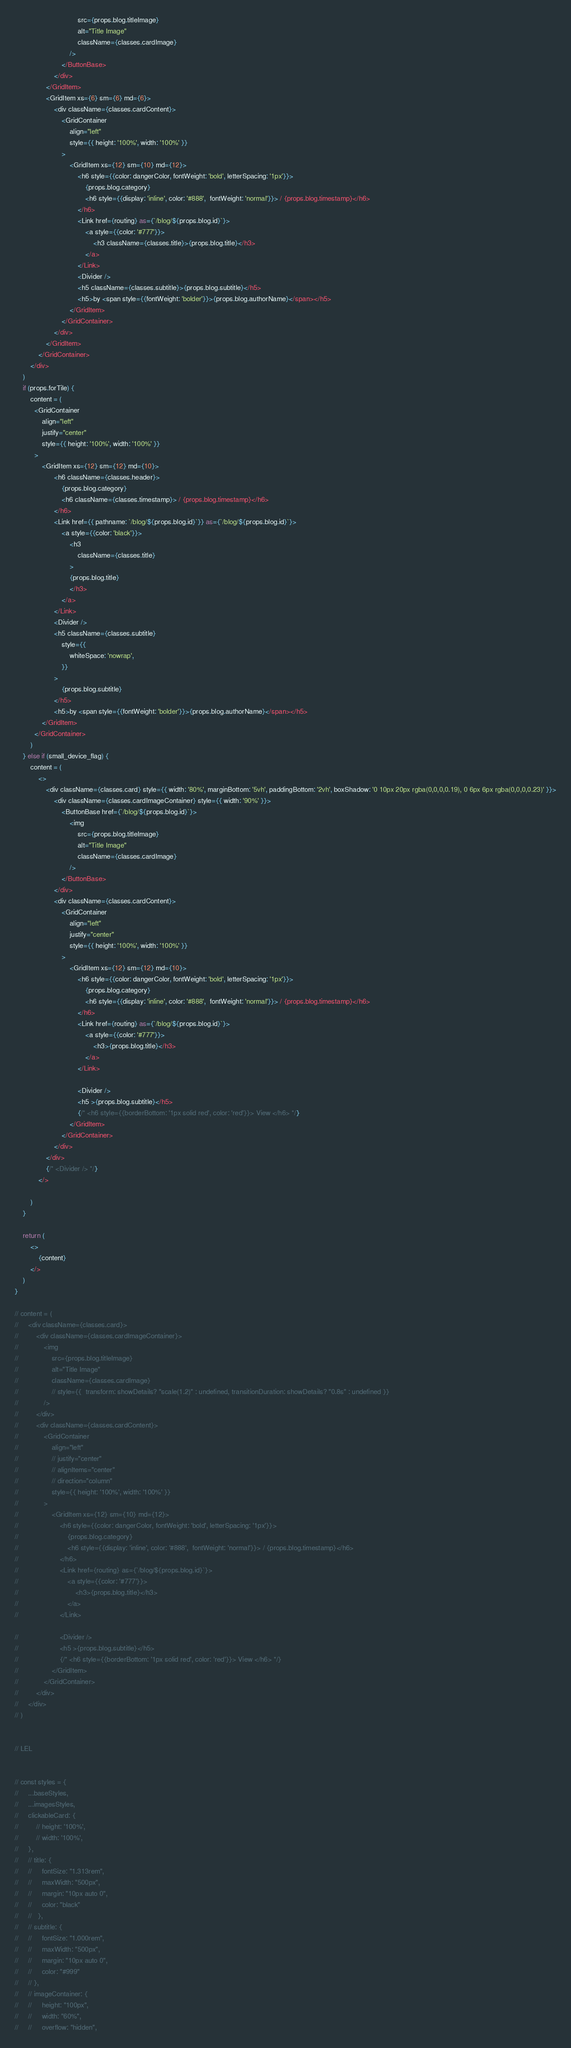Convert code to text. <code><loc_0><loc_0><loc_500><loc_500><_JavaScript_>                                src={props.blog.titleImage}
                                alt="Title Image"
                                className={classes.cardImage}
                            />
                        </ButtonBase>
                    </div>
                </GridItem>
                <GridItem xs={6} sm={6} md={6}>
                    <div className={classes.cardContent}>
                        <GridContainer 
                            align="left" 
                            style={{ height: '100%', width: '100%' }}
                        >
                            <GridItem xs={12} sm={10} md={12}>
                                <h6 style={{color: dangerColor, fontWeight: 'bold', letterSpacing: '1px'}}>
                                    {props.blog.category}
                                    <h6 style={{display: 'inline', color: '#888',  fontWeight: 'normal'}}> / {props.blog.timestamp}</h6>
                                </h6>
                                <Link href={routing} as={`/blog/${props.blog.id}`}>
                                    <a style={{color: '#777'}}>
                                        <h3 className={classes.title}>{props.blog.title}</h3>
                                    </a>
                                </Link>
                                <Divider />
                                <h5 className={classes.subtitle}>{props.blog.subtitle}</h5>
                                <h5>by <span style={{fontWeight: 'bolder'}}>{props.blog.authorName}</span></h5>
                            </GridItem>
                        </GridContainer>
                    </div>
                </GridItem>
            </GridContainer>
        </div>
    )
    if (props.forTile) {
        content = (
          <GridContainer 
              align="left" 
              justify="center" 
              style={{ height: '100%', width: '100%' }}
          >
              <GridItem xs={12} sm={12} md={10}>
                    <h6 className={classes.header}>
                        {props.blog.category}
                        <h6 className={classes.timestamp}> / {props.blog.timestamp}</h6>
                    </h6>
                    <Link href={{ pathname: `/blog/${props.blog.id}`}} as={`/blog/${props.blog.id}`}>
                        <a style={{color: 'black'}}>
                            <h3 
                                className={classes.title} 
                            >
                            {props.blog.title}
                            </h3>
                        </a>
                    </Link>
                    <Divider />
                    <h5 className={classes.subtitle} 
                        style={{
                            whiteSpace: 'nowrap',
                        }}
                    >
                        {props.blog.subtitle}
                    </h5>
                    <h5>by <span style={{fontWeight: 'bolder'}}>{props.blog.authorName}</span></h5>
              </GridItem>   
          </GridContainer>
        )
    } else if (small_device_flag) {
        content = (
            <>
                <div className={classes.card} style={{ width: '80%', marginBottom: '5vh', paddingBottom: '2vh', boxShadow: '0 10px 20px rgba(0,0,0,0.19), 0 6px 6px rgba(0,0,0,0.23)' }}>
                    <div className={classes.cardImageContainer} style={{ width: '90%' }}>
                        <ButtonBase href={`/blog/${props.blog.id}`}>
                            <img
                                src={props.blog.titleImage}
                                alt="Title Image"
                                className={classes.cardImage}
                            />
                        </ButtonBase>
                    </div>
                    <div className={classes.cardContent}>
                        <GridContainer 
                            align="left" 
                            justify="center" 
                            style={{ height: '100%', width: '100%' }}
                        >
                            <GridItem xs={12} sm={12} md={10}>
                                <h6 style={{color: dangerColor, fontWeight: 'bold', letterSpacing: '1px'}}>
                                    {props.blog.category}
                                    <h6 style={{display: 'inline', color: '#888',  fontWeight: 'normal'}}> / {props.blog.timestamp}</h6>
                                </h6>
                                <Link href={routing} as={`/blog/${props.blog.id}`}>
                                    <a style={{color: '#777'}}>
                                        <h3>{props.blog.title}</h3>
                                    </a>
                                </Link>
                                
                                <Divider />
                                <h5 >{props.blog.subtitle}</h5>
                                {/* <h6 style={{borderBottom: '1px solid red', color: 'red'}}> View </h6> */}
                            </GridItem>
                        </GridContainer>
                    </div>
                </div>
                {/* <Divider /> */}
            </>
            
        )
    }

    return (
        <>
            {content}
        </>
    )
}

// content = (
//     <div className={classes.card}>
//         <div className={classes.cardImageContainer}>
//             <img
//                 src={props.blog.titleImage}
//                 alt="Title Image"
//                 className={classes.cardImage}
//                 // style={{  transform: showDetails? "scale(1.2)" : undefined, transitionDuration: showDetails? "0.8s" : undefined }}
//             />
//         </div>
//         <div className={classes.cardContent}>
//             <GridContainer 
//                 align="left" 
//                 // justify="center" 
//                 // alignItems="center" 
//                 // direction="column"
//                 style={{ height: '100%', width: '100%' }}
//             >
//                 <GridItem xs={12} sm={10} md={12}>
//                     <h6 style={{color: dangerColor, fontWeight: 'bold', letterSpacing: '1px'}}>
//                         {props.blog.category}
//                         <h6 style={{display: 'inline', color: '#888',  fontWeight: 'normal'}}> / {props.blog.timestamp}</h6>
//                     </h6>
//                     <Link href={routing} as={`/blog/${props.blog.id}`}>
//                         <a style={{color: '#777'}}>
//                             <h3>{props.blog.title}</h3>
//                         </a>
//                     </Link>
                    
//                     <Divider />
//                     <h5 >{props.blog.subtitle}</h5>
//                     {/* <h6 style={{borderBottom: '1px solid red', color: 'red'}}> View </h6> */}
//                 </GridItem>
//             </GridContainer>
//         </div>
//     </div>
// )


// LEL


// const styles = {
//     ...baseStyles,
//     ...imagesStyles,
//     clickableCard: {
//         // height: '100%',
//         // width: '100%',  
//     },
//     // title: {
//     //     fontSize: "1.313rem",
//     //     maxWidth: "500px",
//     //     margin: "10px auto 0",
//     //     color: "black"
//     //   },
//     // subtitle: {
//     //     fontSize: "1.000rem",
//     //     maxWidth: "500px",
//     //     margin: "10px auto 0",
//     //     color: "#999"
//     // },
//     // imageContainer: {
//     //     height: "100px",
//     //     width: "60%",
//     //     overflow: "hidden",</code> 